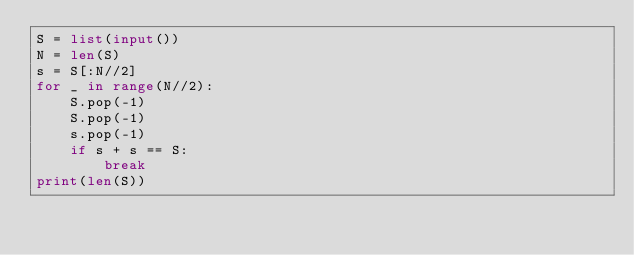<code> <loc_0><loc_0><loc_500><loc_500><_Python_>S = list(input())
N = len(S)
s = S[:N//2]
for _ in range(N//2):
    S.pop(-1)
    S.pop(-1)
    s.pop(-1)
    if s + s == S:
        break
print(len(S))</code> 